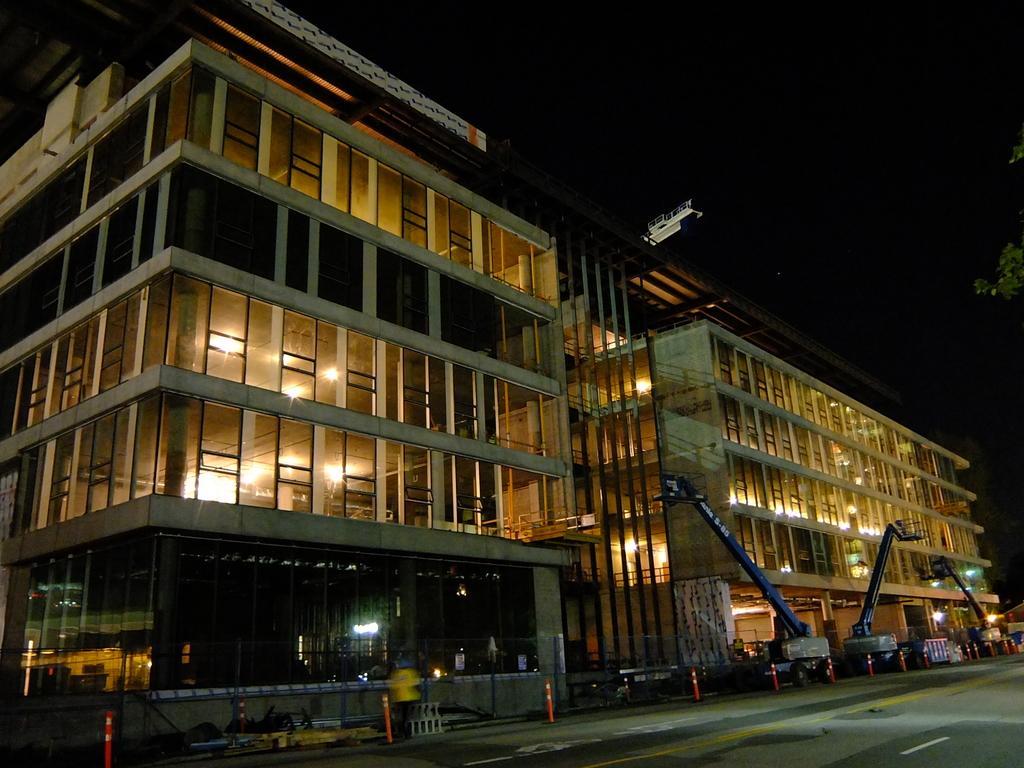How would you summarize this image in a sentence or two? In the center of the image there are buildings. There is road with safety poles and vehicles. At the top of the image there is sky. 